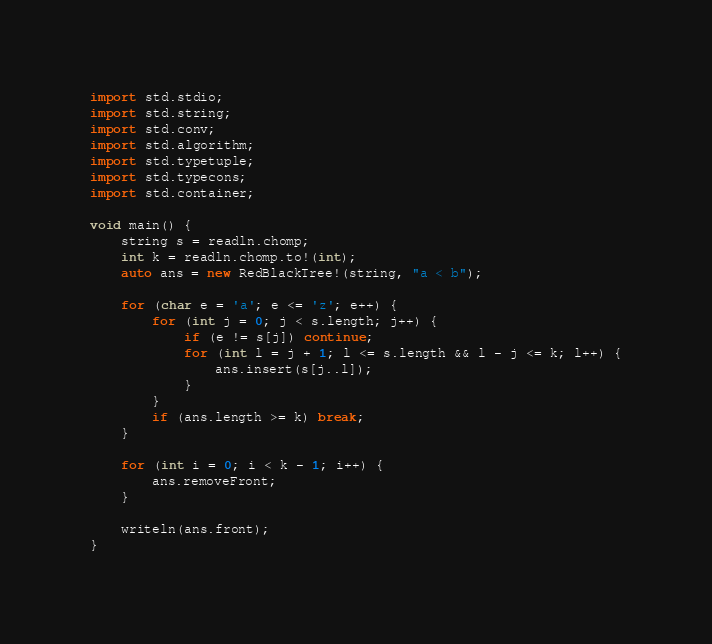<code> <loc_0><loc_0><loc_500><loc_500><_D_>import std.stdio;
import std.string;
import std.conv;
import std.algorithm;
import std.typetuple;
import std.typecons;
import std.container;

void main() {
    string s = readln.chomp;
    int k = readln.chomp.to!(int);
    auto ans = new RedBlackTree!(string, "a < b");

    for (char e = 'a'; e <= 'z'; e++) {
        for (int j = 0; j < s.length; j++) {
            if (e != s[j]) continue;
            for (int l = j + 1; l <= s.length && l - j <= k; l++) {
                ans.insert(s[j..l]);
            }
        }
        if (ans.length >= k) break;
    }

    for (int i = 0; i < k - 1; i++) {
        ans.removeFront;
    }

    writeln(ans.front);
}</code> 